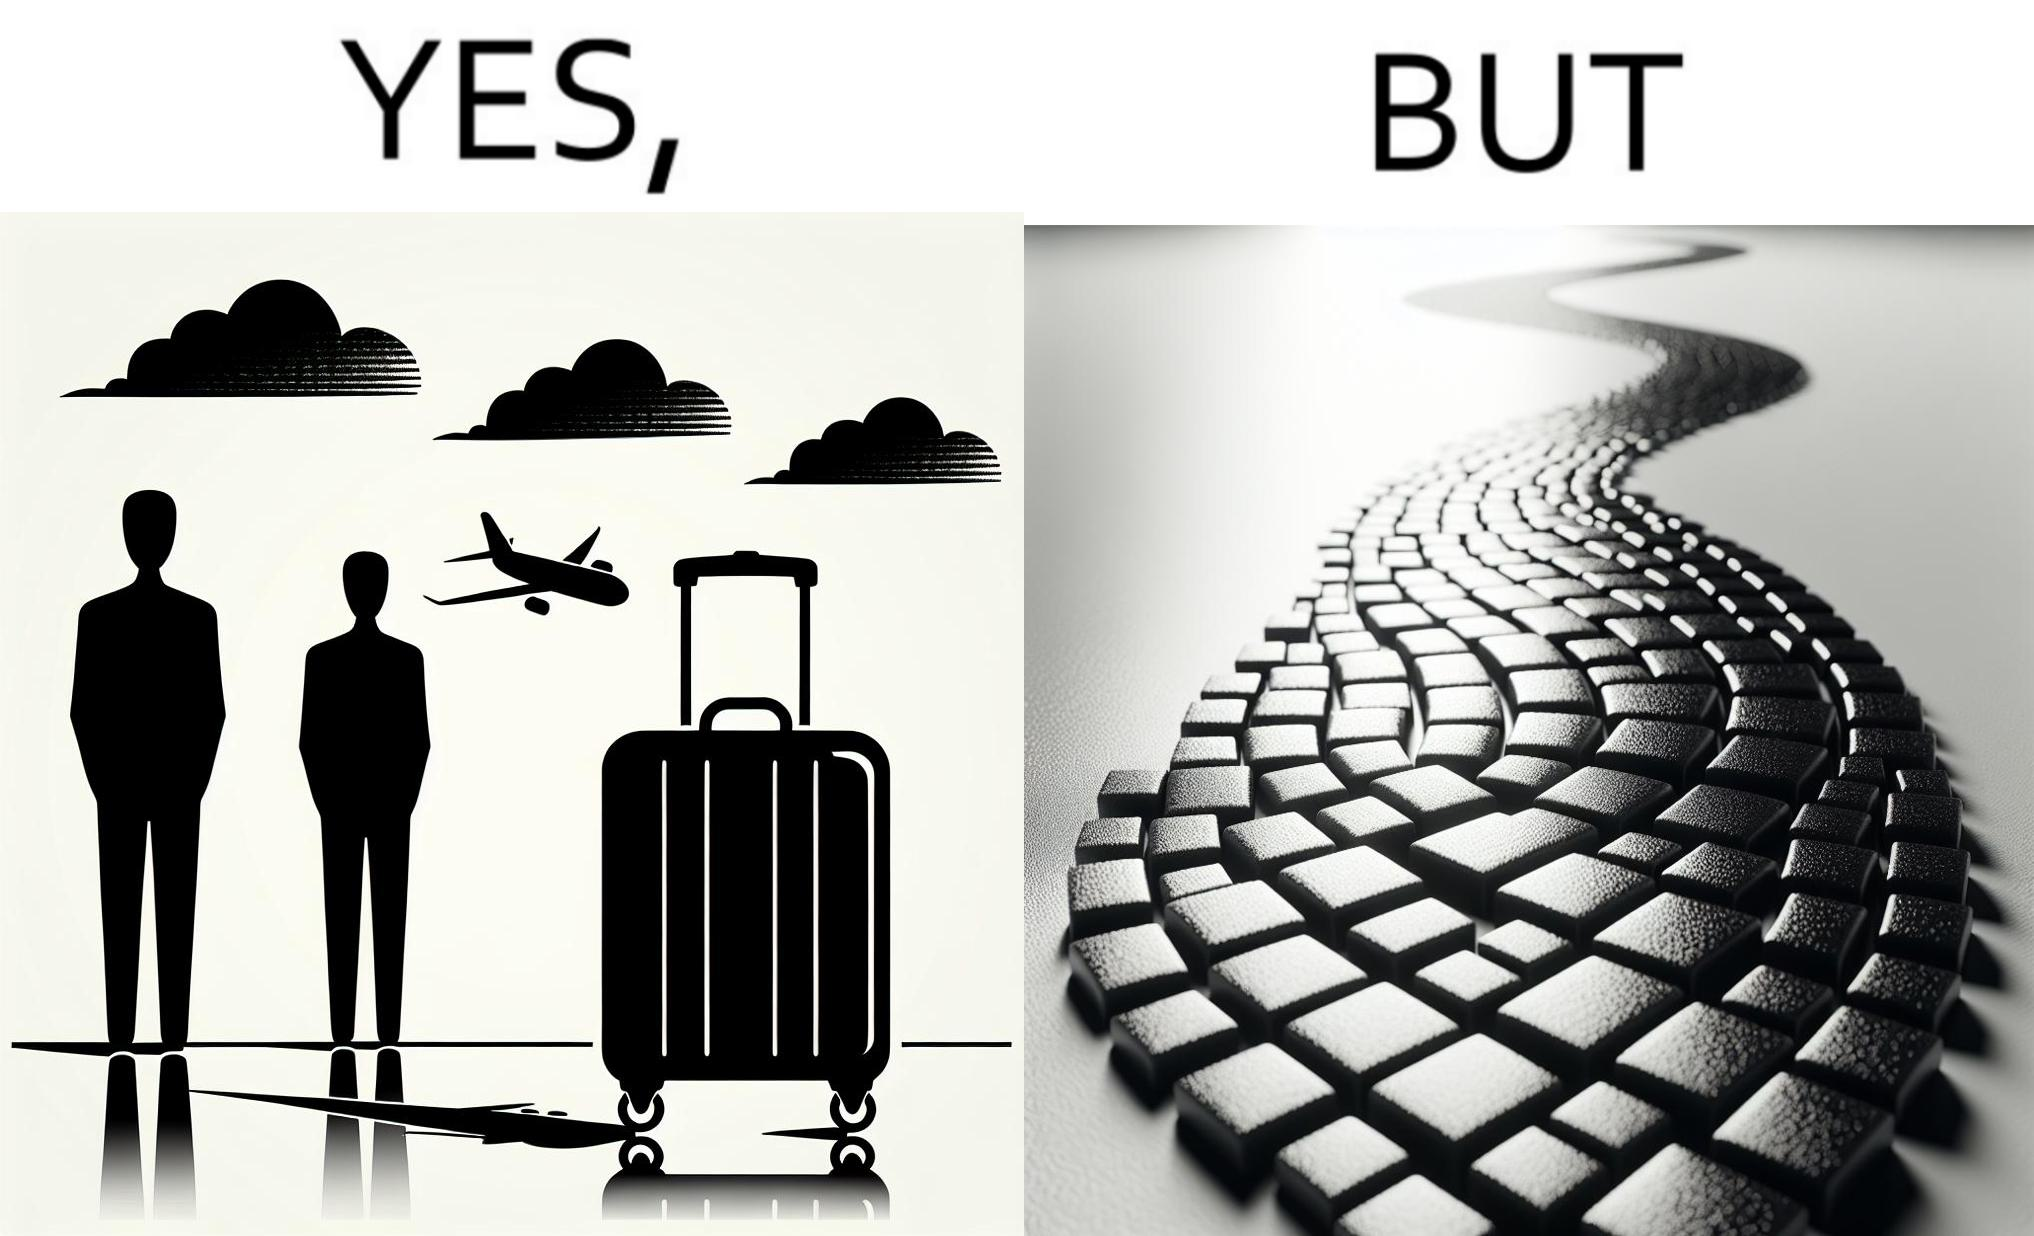Is this image satirical or non-satirical? Yes, this image is satirical. 